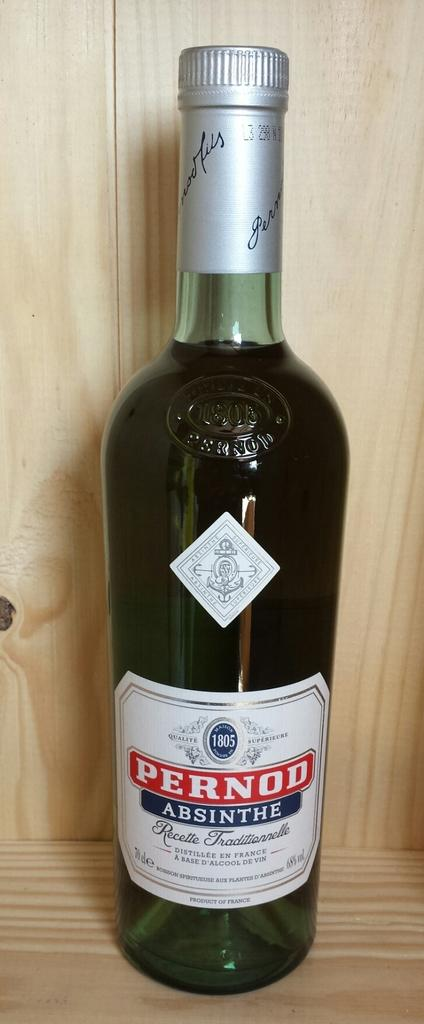Provide a one-sentence caption for the provided image. A bottle of Pernod Absinthe sits on a wooden shelf. 